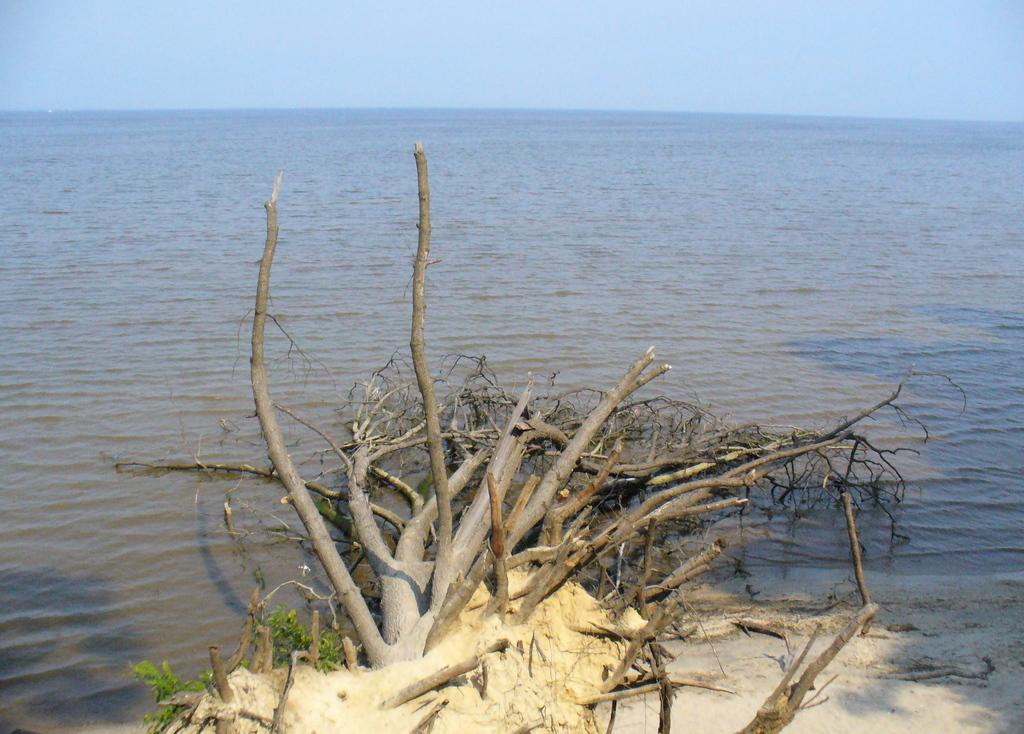What is located in the middle of the image? There is water in the middle of the image. What is visible at the top of the image? The sky is visible at the top of the image. Can you describe the tree in the water? There is a dried tree in the water. What stage of development is the quince tree in the image? There is no quince tree present in the image, only a dried tree in the water. Can you describe the home of the family living in the image? There is no home or family present in the image; it features water, sky, and a dried tree. 